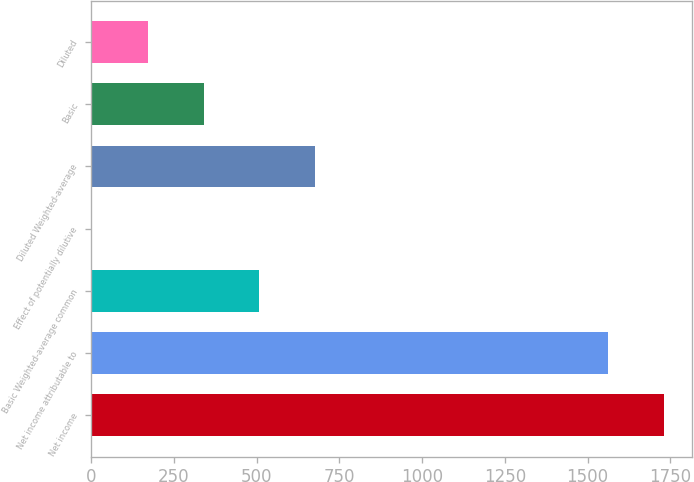Convert chart to OTSL. <chart><loc_0><loc_0><loc_500><loc_500><bar_chart><fcel>Net income<fcel>Net income attributable to<fcel>Basic Weighted-average common<fcel>Effect of potentially dilutive<fcel>Diluted Weighted-average<fcel>Basic<fcel>Diluted<nl><fcel>1730.45<fcel>1562<fcel>507.85<fcel>2.5<fcel>676.3<fcel>339.4<fcel>170.95<nl></chart> 